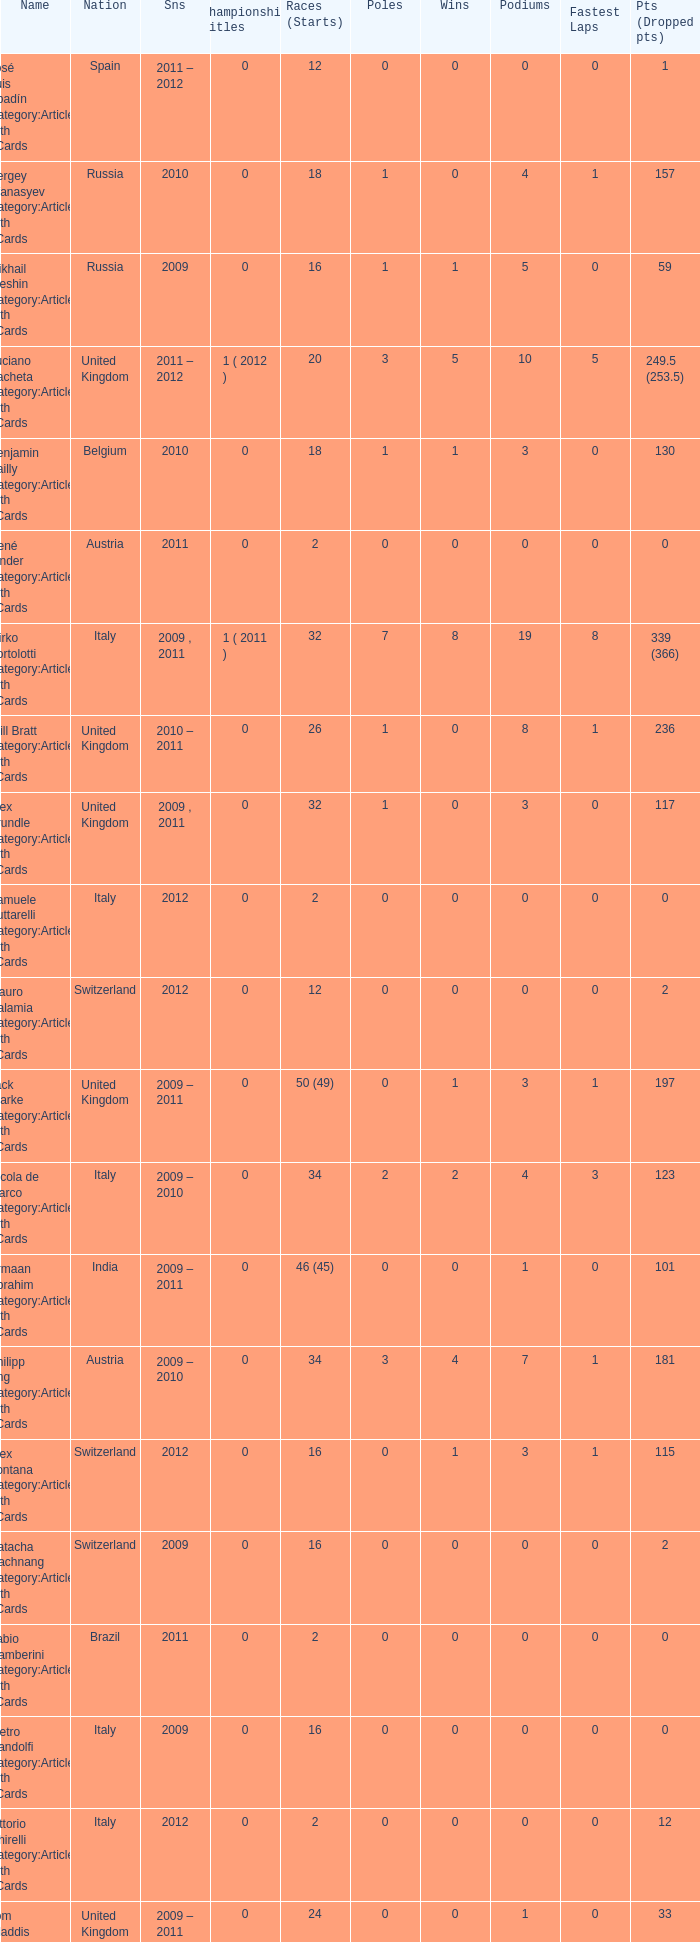At what stage were the points when there was an 18-point drop? 8.0. 